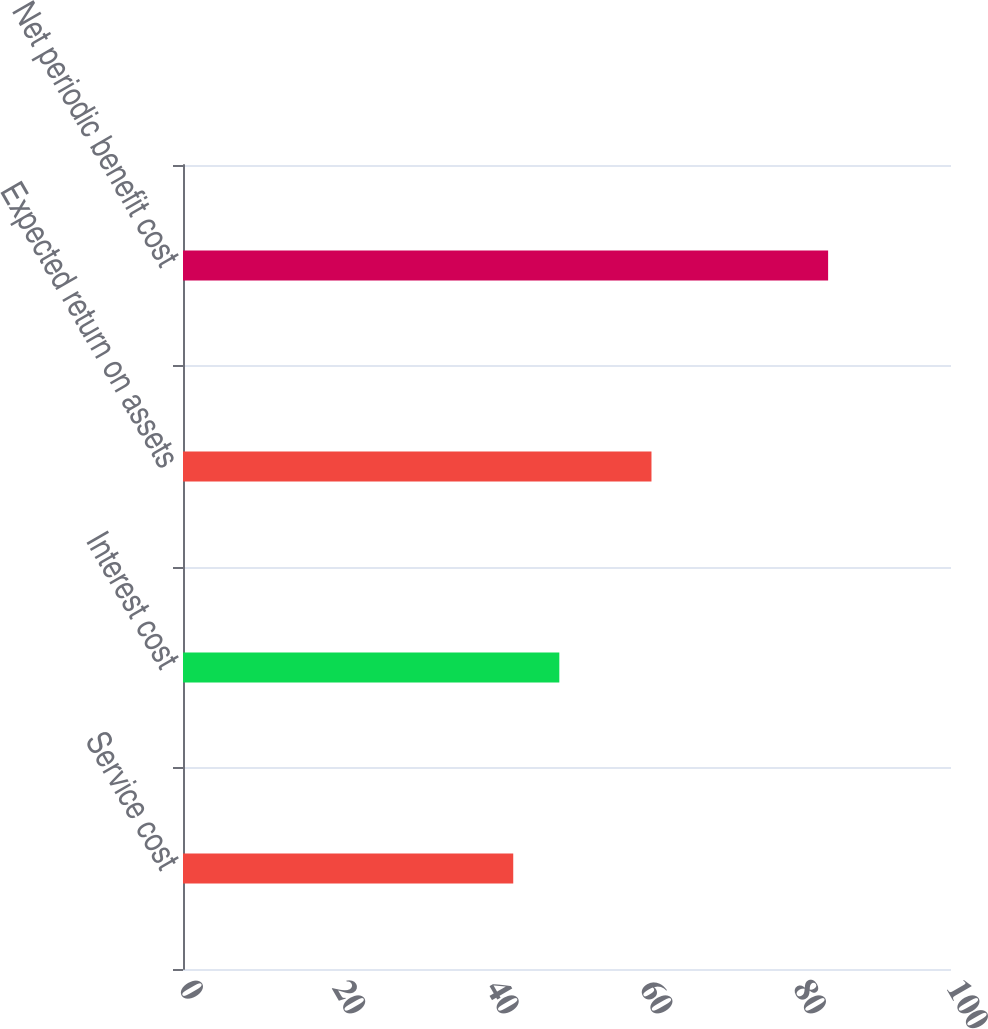Convert chart to OTSL. <chart><loc_0><loc_0><loc_500><loc_500><bar_chart><fcel>Service cost<fcel>Interest cost<fcel>Expected return on assets<fcel>Net periodic benefit cost<nl><fcel>43<fcel>49<fcel>61<fcel>84<nl></chart> 